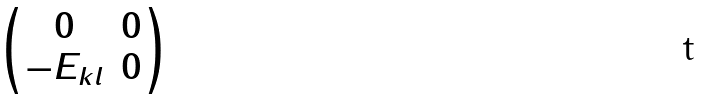Convert formula to latex. <formula><loc_0><loc_0><loc_500><loc_500>\begin{pmatrix} 0 & 0 \\ - E _ { k l } & 0 \end{pmatrix}</formula> 